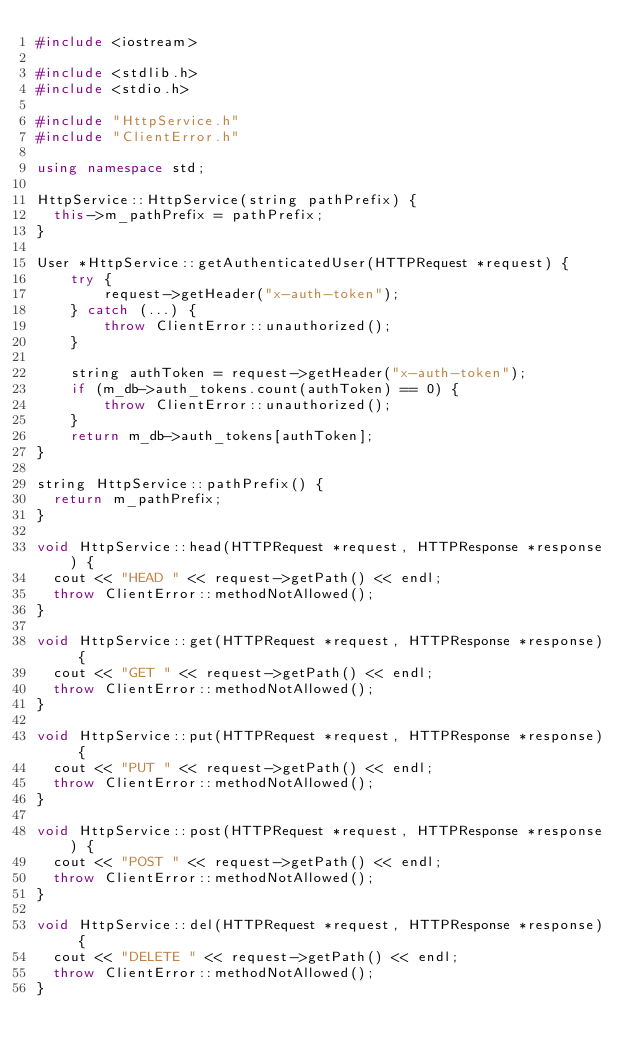Convert code to text. <code><loc_0><loc_0><loc_500><loc_500><_C++_>#include <iostream>

#include <stdlib.h>
#include <stdio.h>

#include "HttpService.h"
#include "ClientError.h"

using namespace std;

HttpService::HttpService(string pathPrefix) {
  this->m_pathPrefix = pathPrefix;
}

User *HttpService::getAuthenticatedUser(HTTPRequest *request) {
    try {
        request->getHeader("x-auth-token");
    } catch (...) {
        throw ClientError::unauthorized();
    }

    string authToken = request->getHeader("x-auth-token");
    if (m_db->auth_tokens.count(authToken) == 0) {
        throw ClientError::unauthorized();
    }
    return m_db->auth_tokens[authToken];
}

string HttpService::pathPrefix() {
  return m_pathPrefix;
}

void HttpService::head(HTTPRequest *request, HTTPResponse *response) {
  cout << "HEAD " << request->getPath() << endl;
  throw ClientError::methodNotAllowed();
}

void HttpService::get(HTTPRequest *request, HTTPResponse *response) {
  cout << "GET " << request->getPath() << endl;
  throw ClientError::methodNotAllowed();
}

void HttpService::put(HTTPRequest *request, HTTPResponse *response) {
  cout << "PUT " << request->getPath() << endl;
  throw ClientError::methodNotAllowed();
}

void HttpService::post(HTTPRequest *request, HTTPResponse *response) {
  cout << "POST " << request->getPath() << endl;
  throw ClientError::methodNotAllowed();
}

void HttpService::del(HTTPRequest *request, HTTPResponse *response) {
  cout << "DELETE " << request->getPath() << endl;
  throw ClientError::methodNotAllowed();
}

</code> 